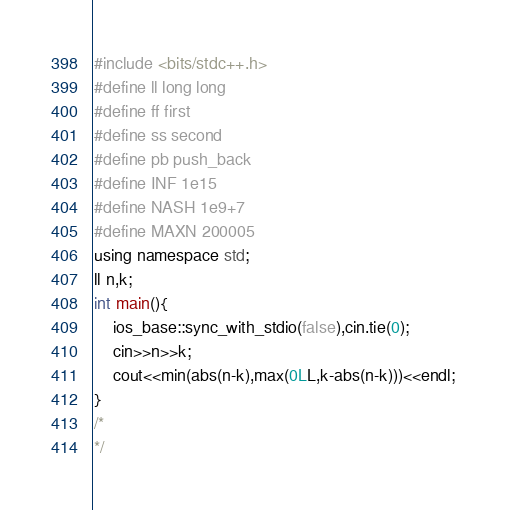<code> <loc_0><loc_0><loc_500><loc_500><_C++_>#include <bits/stdc++.h>
#define ll long long
#define ff first
#define ss second
#define pb push_back
#define INF 1e15
#define NASH 1e9+7
#define MAXN 200005
using namespace std;
ll n,k;
int main(){
    ios_base::sync_with_stdio(false),cin.tie(0);    
    cin>>n>>k;
    cout<<min(abs(n-k),max(0LL,k-abs(n-k)))<<endl;
}
/*
*/</code> 